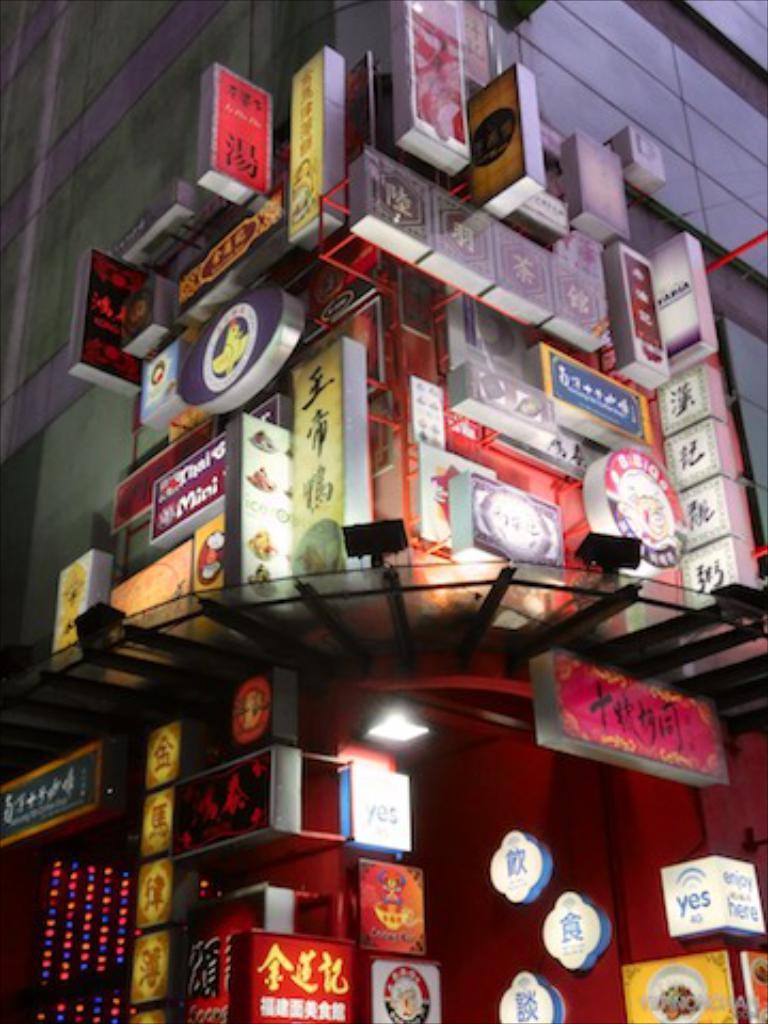Describe this image in one or two sentences. In this image we can see a building with few boards and lights. 